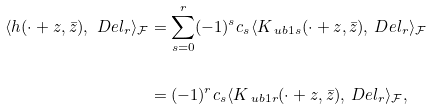<formula> <loc_0><loc_0><loc_500><loc_500>\langle h ( \cdot + z , \bar { z } ) , \ D e l _ { r } \rangle _ { \mathcal { F } } & = \sum _ { s = 0 } ^ { r } ( - 1 ) ^ { s } c _ { s } \langle K _ { \ u b 1 s } ( \cdot + z , \bar { z } ) , \ D e l _ { r } \rangle _ { \mathcal { F } } \\ \\ & = ( - 1 ) ^ { r } c _ { s } \langle K _ { \ u b 1 r } ( \cdot + z , \bar { z } ) , \ D e l _ { r } \rangle _ { \mathcal { F } } ,</formula> 